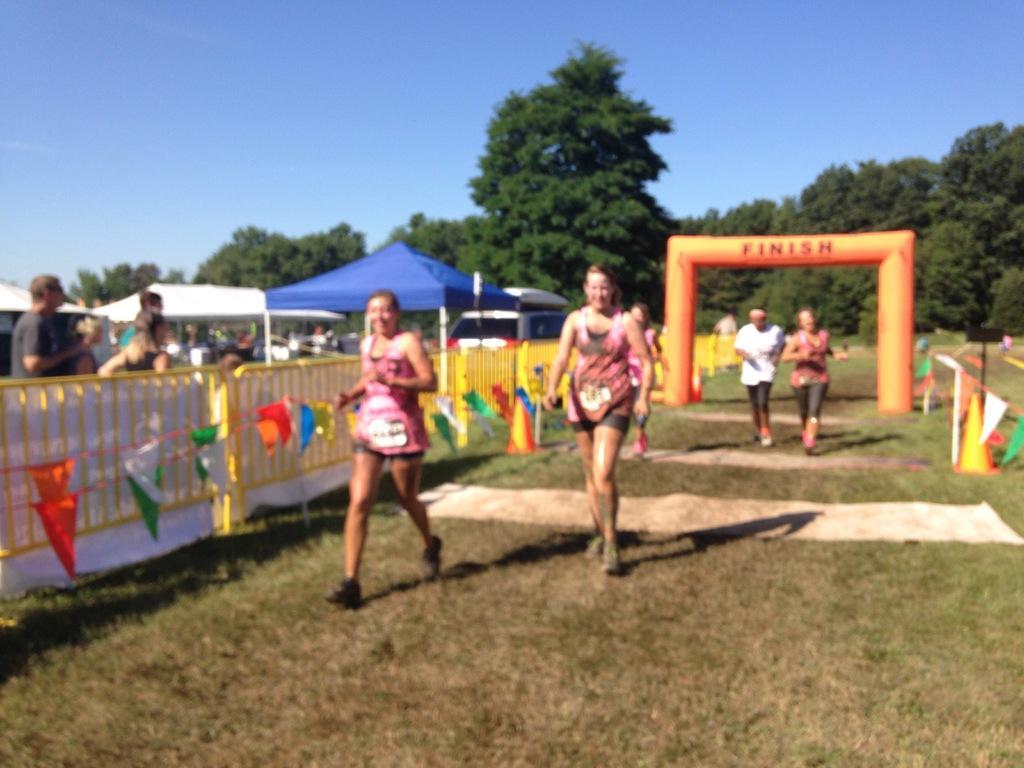In one or two sentences, can you explain what this image depicts? In this picture I can see a group of people among them some are running on the ground. I can also see a fence and stalls. In the background I can see trees and the sky. On the right side I can see some objects on the ground. 